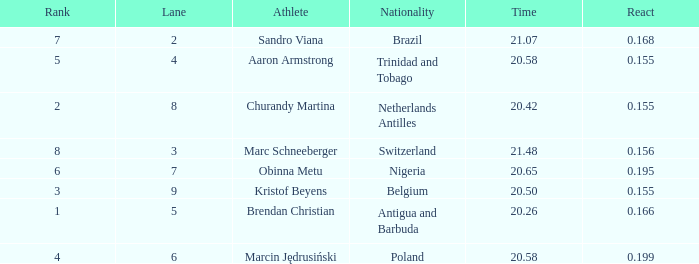How much Time has a Reaction of 0.155, and an Athlete of kristof beyens, and a Rank smaller than 3? 0.0. 